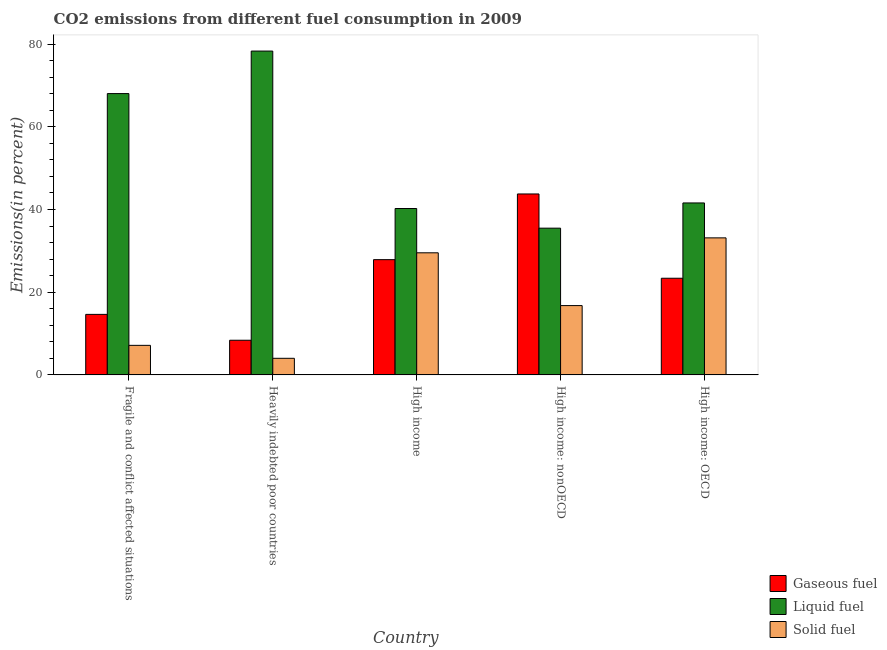How many different coloured bars are there?
Your answer should be compact. 3. Are the number of bars per tick equal to the number of legend labels?
Offer a terse response. Yes. How many bars are there on the 5th tick from the right?
Your response must be concise. 3. What is the label of the 1st group of bars from the left?
Your answer should be compact. Fragile and conflict affected situations. In how many cases, is the number of bars for a given country not equal to the number of legend labels?
Your answer should be compact. 0. What is the percentage of liquid fuel emission in High income?
Give a very brief answer. 40.24. Across all countries, what is the maximum percentage of liquid fuel emission?
Your answer should be compact. 78.31. Across all countries, what is the minimum percentage of gaseous fuel emission?
Your answer should be very brief. 8.38. In which country was the percentage of gaseous fuel emission maximum?
Provide a succinct answer. High income: nonOECD. In which country was the percentage of solid fuel emission minimum?
Offer a very short reply. Heavily indebted poor countries. What is the total percentage of gaseous fuel emission in the graph?
Offer a very short reply. 118.02. What is the difference between the percentage of gaseous fuel emission in Fragile and conflict affected situations and that in Heavily indebted poor countries?
Provide a short and direct response. 6.25. What is the difference between the percentage of gaseous fuel emission in Heavily indebted poor countries and the percentage of solid fuel emission in Fragile and conflict affected situations?
Your response must be concise. 1.24. What is the average percentage of gaseous fuel emission per country?
Make the answer very short. 23.6. What is the difference between the percentage of liquid fuel emission and percentage of gaseous fuel emission in Heavily indebted poor countries?
Your response must be concise. 69.93. What is the ratio of the percentage of solid fuel emission in Heavily indebted poor countries to that in High income?
Make the answer very short. 0.14. Is the difference between the percentage of solid fuel emission in High income and High income: nonOECD greater than the difference between the percentage of gaseous fuel emission in High income and High income: nonOECD?
Offer a terse response. Yes. What is the difference between the highest and the second highest percentage of liquid fuel emission?
Your answer should be very brief. 10.28. What is the difference between the highest and the lowest percentage of liquid fuel emission?
Your response must be concise. 42.82. What does the 2nd bar from the left in Fragile and conflict affected situations represents?
Your answer should be compact. Liquid fuel. What does the 1st bar from the right in Heavily indebted poor countries represents?
Your response must be concise. Solid fuel. Is it the case that in every country, the sum of the percentage of gaseous fuel emission and percentage of liquid fuel emission is greater than the percentage of solid fuel emission?
Ensure brevity in your answer.  Yes. How many countries are there in the graph?
Provide a succinct answer. 5. Does the graph contain any zero values?
Offer a terse response. No. Does the graph contain grids?
Offer a very short reply. No. Where does the legend appear in the graph?
Make the answer very short. Bottom right. What is the title of the graph?
Make the answer very short. CO2 emissions from different fuel consumption in 2009. Does "Unemployment benefits" appear as one of the legend labels in the graph?
Offer a very short reply. No. What is the label or title of the Y-axis?
Ensure brevity in your answer.  Emissions(in percent). What is the Emissions(in percent) in Gaseous fuel in Fragile and conflict affected situations?
Your answer should be very brief. 14.64. What is the Emissions(in percent) of Liquid fuel in Fragile and conflict affected situations?
Your answer should be compact. 68.03. What is the Emissions(in percent) of Solid fuel in Fragile and conflict affected situations?
Keep it short and to the point. 7.15. What is the Emissions(in percent) of Gaseous fuel in Heavily indebted poor countries?
Keep it short and to the point. 8.38. What is the Emissions(in percent) in Liquid fuel in Heavily indebted poor countries?
Make the answer very short. 78.31. What is the Emissions(in percent) of Solid fuel in Heavily indebted poor countries?
Your answer should be very brief. 4.01. What is the Emissions(in percent) in Gaseous fuel in High income?
Keep it short and to the point. 27.87. What is the Emissions(in percent) of Liquid fuel in High income?
Provide a succinct answer. 40.24. What is the Emissions(in percent) of Solid fuel in High income?
Offer a very short reply. 29.53. What is the Emissions(in percent) of Gaseous fuel in High income: nonOECD?
Your answer should be compact. 43.76. What is the Emissions(in percent) of Liquid fuel in High income: nonOECD?
Keep it short and to the point. 35.49. What is the Emissions(in percent) in Solid fuel in High income: nonOECD?
Offer a very short reply. 16.76. What is the Emissions(in percent) of Gaseous fuel in High income: OECD?
Offer a very short reply. 23.38. What is the Emissions(in percent) in Liquid fuel in High income: OECD?
Provide a succinct answer. 41.58. What is the Emissions(in percent) in Solid fuel in High income: OECD?
Keep it short and to the point. 33.14. Across all countries, what is the maximum Emissions(in percent) of Gaseous fuel?
Give a very brief answer. 43.76. Across all countries, what is the maximum Emissions(in percent) in Liquid fuel?
Make the answer very short. 78.31. Across all countries, what is the maximum Emissions(in percent) of Solid fuel?
Offer a terse response. 33.14. Across all countries, what is the minimum Emissions(in percent) in Gaseous fuel?
Your answer should be very brief. 8.38. Across all countries, what is the minimum Emissions(in percent) in Liquid fuel?
Your response must be concise. 35.49. Across all countries, what is the minimum Emissions(in percent) in Solid fuel?
Make the answer very short. 4.01. What is the total Emissions(in percent) in Gaseous fuel in the graph?
Ensure brevity in your answer.  118.02. What is the total Emissions(in percent) of Liquid fuel in the graph?
Give a very brief answer. 263.65. What is the total Emissions(in percent) in Solid fuel in the graph?
Keep it short and to the point. 90.59. What is the difference between the Emissions(in percent) of Gaseous fuel in Fragile and conflict affected situations and that in Heavily indebted poor countries?
Make the answer very short. 6.25. What is the difference between the Emissions(in percent) of Liquid fuel in Fragile and conflict affected situations and that in Heavily indebted poor countries?
Offer a terse response. -10.28. What is the difference between the Emissions(in percent) of Solid fuel in Fragile and conflict affected situations and that in Heavily indebted poor countries?
Your answer should be compact. 3.13. What is the difference between the Emissions(in percent) of Gaseous fuel in Fragile and conflict affected situations and that in High income?
Offer a very short reply. -13.23. What is the difference between the Emissions(in percent) of Liquid fuel in Fragile and conflict affected situations and that in High income?
Provide a short and direct response. 27.79. What is the difference between the Emissions(in percent) in Solid fuel in Fragile and conflict affected situations and that in High income?
Offer a very short reply. -22.38. What is the difference between the Emissions(in percent) of Gaseous fuel in Fragile and conflict affected situations and that in High income: nonOECD?
Offer a very short reply. -29.12. What is the difference between the Emissions(in percent) of Liquid fuel in Fragile and conflict affected situations and that in High income: nonOECD?
Offer a very short reply. 32.54. What is the difference between the Emissions(in percent) of Solid fuel in Fragile and conflict affected situations and that in High income: nonOECD?
Your answer should be very brief. -9.62. What is the difference between the Emissions(in percent) in Gaseous fuel in Fragile and conflict affected situations and that in High income: OECD?
Make the answer very short. -8.74. What is the difference between the Emissions(in percent) in Liquid fuel in Fragile and conflict affected situations and that in High income: OECD?
Ensure brevity in your answer.  26.44. What is the difference between the Emissions(in percent) of Solid fuel in Fragile and conflict affected situations and that in High income: OECD?
Your answer should be compact. -25.99. What is the difference between the Emissions(in percent) in Gaseous fuel in Heavily indebted poor countries and that in High income?
Ensure brevity in your answer.  -19.49. What is the difference between the Emissions(in percent) in Liquid fuel in Heavily indebted poor countries and that in High income?
Your response must be concise. 38.07. What is the difference between the Emissions(in percent) in Solid fuel in Heavily indebted poor countries and that in High income?
Your answer should be compact. -25.51. What is the difference between the Emissions(in percent) in Gaseous fuel in Heavily indebted poor countries and that in High income: nonOECD?
Make the answer very short. -35.37. What is the difference between the Emissions(in percent) of Liquid fuel in Heavily indebted poor countries and that in High income: nonOECD?
Keep it short and to the point. 42.82. What is the difference between the Emissions(in percent) in Solid fuel in Heavily indebted poor countries and that in High income: nonOECD?
Provide a short and direct response. -12.75. What is the difference between the Emissions(in percent) of Gaseous fuel in Heavily indebted poor countries and that in High income: OECD?
Offer a very short reply. -14.99. What is the difference between the Emissions(in percent) of Liquid fuel in Heavily indebted poor countries and that in High income: OECD?
Offer a terse response. 36.72. What is the difference between the Emissions(in percent) in Solid fuel in Heavily indebted poor countries and that in High income: OECD?
Offer a terse response. -29.12. What is the difference between the Emissions(in percent) of Gaseous fuel in High income and that in High income: nonOECD?
Your response must be concise. -15.89. What is the difference between the Emissions(in percent) in Liquid fuel in High income and that in High income: nonOECD?
Offer a very short reply. 4.75. What is the difference between the Emissions(in percent) of Solid fuel in High income and that in High income: nonOECD?
Keep it short and to the point. 12.76. What is the difference between the Emissions(in percent) in Gaseous fuel in High income and that in High income: OECD?
Provide a short and direct response. 4.49. What is the difference between the Emissions(in percent) of Liquid fuel in High income and that in High income: OECD?
Ensure brevity in your answer.  -1.34. What is the difference between the Emissions(in percent) of Solid fuel in High income and that in High income: OECD?
Provide a short and direct response. -3.61. What is the difference between the Emissions(in percent) in Gaseous fuel in High income: nonOECD and that in High income: OECD?
Provide a short and direct response. 20.38. What is the difference between the Emissions(in percent) of Liquid fuel in High income: nonOECD and that in High income: OECD?
Your answer should be compact. -6.1. What is the difference between the Emissions(in percent) of Solid fuel in High income: nonOECD and that in High income: OECD?
Your answer should be very brief. -16.37. What is the difference between the Emissions(in percent) of Gaseous fuel in Fragile and conflict affected situations and the Emissions(in percent) of Liquid fuel in Heavily indebted poor countries?
Make the answer very short. -63.67. What is the difference between the Emissions(in percent) of Gaseous fuel in Fragile and conflict affected situations and the Emissions(in percent) of Solid fuel in Heavily indebted poor countries?
Your answer should be compact. 10.62. What is the difference between the Emissions(in percent) of Liquid fuel in Fragile and conflict affected situations and the Emissions(in percent) of Solid fuel in Heavily indebted poor countries?
Your response must be concise. 64.01. What is the difference between the Emissions(in percent) of Gaseous fuel in Fragile and conflict affected situations and the Emissions(in percent) of Liquid fuel in High income?
Provide a succinct answer. -25.6. What is the difference between the Emissions(in percent) of Gaseous fuel in Fragile and conflict affected situations and the Emissions(in percent) of Solid fuel in High income?
Your answer should be compact. -14.89. What is the difference between the Emissions(in percent) of Liquid fuel in Fragile and conflict affected situations and the Emissions(in percent) of Solid fuel in High income?
Provide a succinct answer. 38.5. What is the difference between the Emissions(in percent) of Gaseous fuel in Fragile and conflict affected situations and the Emissions(in percent) of Liquid fuel in High income: nonOECD?
Provide a short and direct response. -20.85. What is the difference between the Emissions(in percent) in Gaseous fuel in Fragile and conflict affected situations and the Emissions(in percent) in Solid fuel in High income: nonOECD?
Provide a succinct answer. -2.13. What is the difference between the Emissions(in percent) of Liquid fuel in Fragile and conflict affected situations and the Emissions(in percent) of Solid fuel in High income: nonOECD?
Your answer should be compact. 51.26. What is the difference between the Emissions(in percent) in Gaseous fuel in Fragile and conflict affected situations and the Emissions(in percent) in Liquid fuel in High income: OECD?
Provide a succinct answer. -26.95. What is the difference between the Emissions(in percent) in Gaseous fuel in Fragile and conflict affected situations and the Emissions(in percent) in Solid fuel in High income: OECD?
Ensure brevity in your answer.  -18.5. What is the difference between the Emissions(in percent) of Liquid fuel in Fragile and conflict affected situations and the Emissions(in percent) of Solid fuel in High income: OECD?
Make the answer very short. 34.89. What is the difference between the Emissions(in percent) in Gaseous fuel in Heavily indebted poor countries and the Emissions(in percent) in Liquid fuel in High income?
Provide a succinct answer. -31.86. What is the difference between the Emissions(in percent) in Gaseous fuel in Heavily indebted poor countries and the Emissions(in percent) in Solid fuel in High income?
Give a very brief answer. -21.14. What is the difference between the Emissions(in percent) of Liquid fuel in Heavily indebted poor countries and the Emissions(in percent) of Solid fuel in High income?
Give a very brief answer. 48.78. What is the difference between the Emissions(in percent) of Gaseous fuel in Heavily indebted poor countries and the Emissions(in percent) of Liquid fuel in High income: nonOECD?
Your answer should be compact. -27.1. What is the difference between the Emissions(in percent) in Gaseous fuel in Heavily indebted poor countries and the Emissions(in percent) in Solid fuel in High income: nonOECD?
Offer a very short reply. -8.38. What is the difference between the Emissions(in percent) of Liquid fuel in Heavily indebted poor countries and the Emissions(in percent) of Solid fuel in High income: nonOECD?
Offer a very short reply. 61.54. What is the difference between the Emissions(in percent) in Gaseous fuel in Heavily indebted poor countries and the Emissions(in percent) in Liquid fuel in High income: OECD?
Your response must be concise. -33.2. What is the difference between the Emissions(in percent) in Gaseous fuel in Heavily indebted poor countries and the Emissions(in percent) in Solid fuel in High income: OECD?
Provide a succinct answer. -24.75. What is the difference between the Emissions(in percent) of Liquid fuel in Heavily indebted poor countries and the Emissions(in percent) of Solid fuel in High income: OECD?
Provide a short and direct response. 45.17. What is the difference between the Emissions(in percent) of Gaseous fuel in High income and the Emissions(in percent) of Liquid fuel in High income: nonOECD?
Your answer should be compact. -7.62. What is the difference between the Emissions(in percent) in Gaseous fuel in High income and the Emissions(in percent) in Solid fuel in High income: nonOECD?
Your answer should be very brief. 11.11. What is the difference between the Emissions(in percent) of Liquid fuel in High income and the Emissions(in percent) of Solid fuel in High income: nonOECD?
Offer a terse response. 23.48. What is the difference between the Emissions(in percent) of Gaseous fuel in High income and the Emissions(in percent) of Liquid fuel in High income: OECD?
Ensure brevity in your answer.  -13.71. What is the difference between the Emissions(in percent) of Gaseous fuel in High income and the Emissions(in percent) of Solid fuel in High income: OECD?
Give a very brief answer. -5.27. What is the difference between the Emissions(in percent) of Liquid fuel in High income and the Emissions(in percent) of Solid fuel in High income: OECD?
Make the answer very short. 7.1. What is the difference between the Emissions(in percent) of Gaseous fuel in High income: nonOECD and the Emissions(in percent) of Liquid fuel in High income: OECD?
Your answer should be very brief. 2.17. What is the difference between the Emissions(in percent) in Gaseous fuel in High income: nonOECD and the Emissions(in percent) in Solid fuel in High income: OECD?
Give a very brief answer. 10.62. What is the difference between the Emissions(in percent) of Liquid fuel in High income: nonOECD and the Emissions(in percent) of Solid fuel in High income: OECD?
Your response must be concise. 2.35. What is the average Emissions(in percent) in Gaseous fuel per country?
Keep it short and to the point. 23.6. What is the average Emissions(in percent) of Liquid fuel per country?
Provide a short and direct response. 52.73. What is the average Emissions(in percent) of Solid fuel per country?
Your response must be concise. 18.12. What is the difference between the Emissions(in percent) of Gaseous fuel and Emissions(in percent) of Liquid fuel in Fragile and conflict affected situations?
Your answer should be compact. -53.39. What is the difference between the Emissions(in percent) of Gaseous fuel and Emissions(in percent) of Solid fuel in Fragile and conflict affected situations?
Provide a short and direct response. 7.49. What is the difference between the Emissions(in percent) in Liquid fuel and Emissions(in percent) in Solid fuel in Fragile and conflict affected situations?
Offer a very short reply. 60.88. What is the difference between the Emissions(in percent) of Gaseous fuel and Emissions(in percent) of Liquid fuel in Heavily indebted poor countries?
Make the answer very short. -69.93. What is the difference between the Emissions(in percent) of Gaseous fuel and Emissions(in percent) of Solid fuel in Heavily indebted poor countries?
Make the answer very short. 4.37. What is the difference between the Emissions(in percent) of Liquid fuel and Emissions(in percent) of Solid fuel in Heavily indebted poor countries?
Make the answer very short. 74.3. What is the difference between the Emissions(in percent) in Gaseous fuel and Emissions(in percent) in Liquid fuel in High income?
Provide a short and direct response. -12.37. What is the difference between the Emissions(in percent) in Gaseous fuel and Emissions(in percent) in Solid fuel in High income?
Your response must be concise. -1.66. What is the difference between the Emissions(in percent) in Liquid fuel and Emissions(in percent) in Solid fuel in High income?
Offer a very short reply. 10.71. What is the difference between the Emissions(in percent) of Gaseous fuel and Emissions(in percent) of Liquid fuel in High income: nonOECD?
Ensure brevity in your answer.  8.27. What is the difference between the Emissions(in percent) in Gaseous fuel and Emissions(in percent) in Solid fuel in High income: nonOECD?
Your answer should be very brief. 26.99. What is the difference between the Emissions(in percent) in Liquid fuel and Emissions(in percent) in Solid fuel in High income: nonOECD?
Offer a very short reply. 18.72. What is the difference between the Emissions(in percent) of Gaseous fuel and Emissions(in percent) of Liquid fuel in High income: OECD?
Provide a succinct answer. -18.21. What is the difference between the Emissions(in percent) of Gaseous fuel and Emissions(in percent) of Solid fuel in High income: OECD?
Provide a succinct answer. -9.76. What is the difference between the Emissions(in percent) of Liquid fuel and Emissions(in percent) of Solid fuel in High income: OECD?
Your answer should be compact. 8.45. What is the ratio of the Emissions(in percent) of Gaseous fuel in Fragile and conflict affected situations to that in Heavily indebted poor countries?
Provide a succinct answer. 1.75. What is the ratio of the Emissions(in percent) in Liquid fuel in Fragile and conflict affected situations to that in Heavily indebted poor countries?
Your response must be concise. 0.87. What is the ratio of the Emissions(in percent) of Solid fuel in Fragile and conflict affected situations to that in Heavily indebted poor countries?
Your answer should be very brief. 1.78. What is the ratio of the Emissions(in percent) in Gaseous fuel in Fragile and conflict affected situations to that in High income?
Provide a succinct answer. 0.53. What is the ratio of the Emissions(in percent) in Liquid fuel in Fragile and conflict affected situations to that in High income?
Give a very brief answer. 1.69. What is the ratio of the Emissions(in percent) in Solid fuel in Fragile and conflict affected situations to that in High income?
Make the answer very short. 0.24. What is the ratio of the Emissions(in percent) of Gaseous fuel in Fragile and conflict affected situations to that in High income: nonOECD?
Offer a terse response. 0.33. What is the ratio of the Emissions(in percent) in Liquid fuel in Fragile and conflict affected situations to that in High income: nonOECD?
Offer a very short reply. 1.92. What is the ratio of the Emissions(in percent) in Solid fuel in Fragile and conflict affected situations to that in High income: nonOECD?
Your response must be concise. 0.43. What is the ratio of the Emissions(in percent) in Gaseous fuel in Fragile and conflict affected situations to that in High income: OECD?
Give a very brief answer. 0.63. What is the ratio of the Emissions(in percent) of Liquid fuel in Fragile and conflict affected situations to that in High income: OECD?
Your answer should be very brief. 1.64. What is the ratio of the Emissions(in percent) in Solid fuel in Fragile and conflict affected situations to that in High income: OECD?
Offer a terse response. 0.22. What is the ratio of the Emissions(in percent) in Gaseous fuel in Heavily indebted poor countries to that in High income?
Offer a terse response. 0.3. What is the ratio of the Emissions(in percent) of Liquid fuel in Heavily indebted poor countries to that in High income?
Keep it short and to the point. 1.95. What is the ratio of the Emissions(in percent) in Solid fuel in Heavily indebted poor countries to that in High income?
Offer a terse response. 0.14. What is the ratio of the Emissions(in percent) of Gaseous fuel in Heavily indebted poor countries to that in High income: nonOECD?
Keep it short and to the point. 0.19. What is the ratio of the Emissions(in percent) in Liquid fuel in Heavily indebted poor countries to that in High income: nonOECD?
Keep it short and to the point. 2.21. What is the ratio of the Emissions(in percent) of Solid fuel in Heavily indebted poor countries to that in High income: nonOECD?
Offer a very short reply. 0.24. What is the ratio of the Emissions(in percent) in Gaseous fuel in Heavily indebted poor countries to that in High income: OECD?
Your answer should be compact. 0.36. What is the ratio of the Emissions(in percent) in Liquid fuel in Heavily indebted poor countries to that in High income: OECD?
Keep it short and to the point. 1.88. What is the ratio of the Emissions(in percent) of Solid fuel in Heavily indebted poor countries to that in High income: OECD?
Your response must be concise. 0.12. What is the ratio of the Emissions(in percent) in Gaseous fuel in High income to that in High income: nonOECD?
Keep it short and to the point. 0.64. What is the ratio of the Emissions(in percent) of Liquid fuel in High income to that in High income: nonOECD?
Give a very brief answer. 1.13. What is the ratio of the Emissions(in percent) in Solid fuel in High income to that in High income: nonOECD?
Ensure brevity in your answer.  1.76. What is the ratio of the Emissions(in percent) of Gaseous fuel in High income to that in High income: OECD?
Your response must be concise. 1.19. What is the ratio of the Emissions(in percent) of Solid fuel in High income to that in High income: OECD?
Provide a succinct answer. 0.89. What is the ratio of the Emissions(in percent) of Gaseous fuel in High income: nonOECD to that in High income: OECD?
Your response must be concise. 1.87. What is the ratio of the Emissions(in percent) of Liquid fuel in High income: nonOECD to that in High income: OECD?
Provide a short and direct response. 0.85. What is the ratio of the Emissions(in percent) of Solid fuel in High income: nonOECD to that in High income: OECD?
Your answer should be compact. 0.51. What is the difference between the highest and the second highest Emissions(in percent) in Gaseous fuel?
Your response must be concise. 15.89. What is the difference between the highest and the second highest Emissions(in percent) of Liquid fuel?
Keep it short and to the point. 10.28. What is the difference between the highest and the second highest Emissions(in percent) in Solid fuel?
Provide a succinct answer. 3.61. What is the difference between the highest and the lowest Emissions(in percent) in Gaseous fuel?
Provide a succinct answer. 35.37. What is the difference between the highest and the lowest Emissions(in percent) of Liquid fuel?
Offer a very short reply. 42.82. What is the difference between the highest and the lowest Emissions(in percent) in Solid fuel?
Provide a short and direct response. 29.12. 